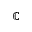Convert formula to latex. <formula><loc_0><loc_0><loc_500><loc_500>\mathbb { C }</formula> 